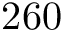<formula> <loc_0><loc_0><loc_500><loc_500>2 6 0</formula> 